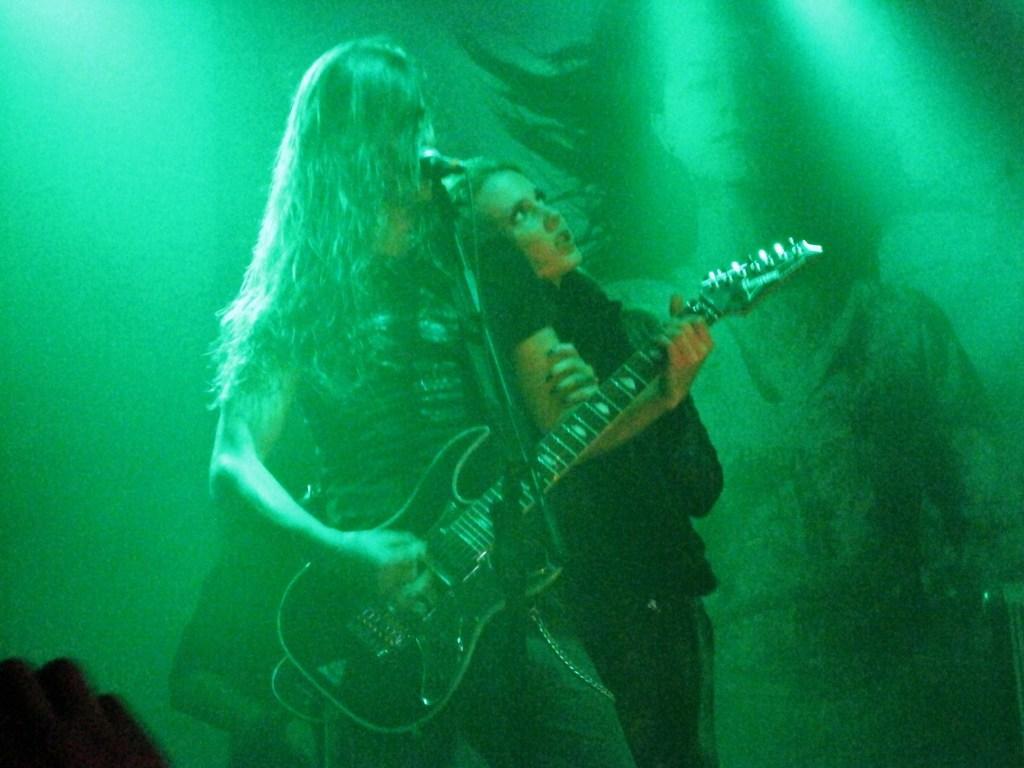In one or two sentences, can you explain what this image depicts? In the middle of the image a person is standing and playing guitar and there is a microphone. Behind the person there is a woman standing and watching. Bottom left side of the image a person is standing. Top right side of the image there is a screen on the screen there is a person standing. 